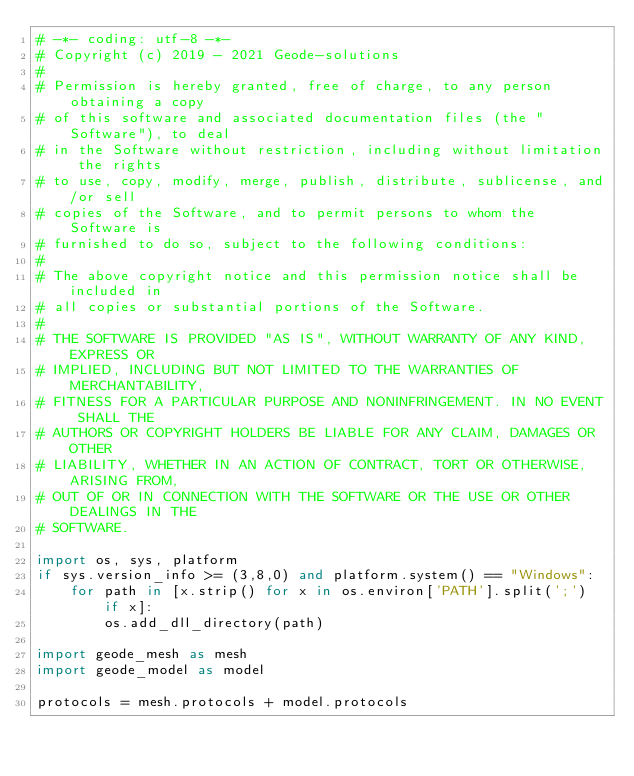<code> <loc_0><loc_0><loc_500><loc_500><_Python_># -*- coding: utf-8 -*-
# Copyright (c) 2019 - 2021 Geode-solutions
#
# Permission is hereby granted, free of charge, to any person obtaining a copy
# of this software and associated documentation files (the "Software"), to deal
# in the Software without restriction, including without limitation the rights
# to use, copy, modify, merge, publish, distribute, sublicense, and/or sell
# copies of the Software, and to permit persons to whom the Software is
# furnished to do so, subject to the following conditions:
#
# The above copyright notice and this permission notice shall be included in
# all copies or substantial portions of the Software.
#
# THE SOFTWARE IS PROVIDED "AS IS", WITHOUT WARRANTY OF ANY KIND, EXPRESS OR
# IMPLIED, INCLUDING BUT NOT LIMITED TO THE WARRANTIES OF MERCHANTABILITY,
# FITNESS FOR A PARTICULAR PURPOSE AND NONINFRINGEMENT. IN NO EVENT SHALL THE
# AUTHORS OR COPYRIGHT HOLDERS BE LIABLE FOR ANY CLAIM, DAMAGES OR OTHER
# LIABILITY, WHETHER IN AN ACTION OF CONTRACT, TORT OR OTHERWISE, ARISING FROM,
# OUT OF OR IN CONNECTION WITH THE SOFTWARE OR THE USE OR OTHER DEALINGS IN THE
# SOFTWARE.

import os, sys, platform
if sys.version_info >= (3,8,0) and platform.system() == "Windows":
    for path in [x.strip() for x in os.environ['PATH'].split(';') if x]:
        os.add_dll_directory(path)

import geode_mesh as mesh
import geode_model as model

protocols = mesh.protocols + model.protocols</code> 